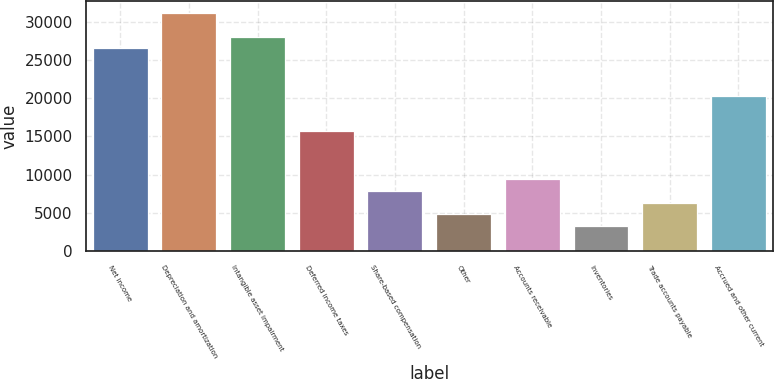Convert chart to OTSL. <chart><loc_0><loc_0><loc_500><loc_500><bar_chart><fcel>Net income<fcel>Depreciation and amortization<fcel>Intangible asset impairment<fcel>Deferred income taxes<fcel>Share-based compensation<fcel>Other<fcel>Accounts receivable<fcel>Inventories<fcel>Trade accounts payable<fcel>Accrued and other current<nl><fcel>26519.9<fcel>31178<fcel>28072.6<fcel>15651<fcel>7887.5<fcel>4782.1<fcel>9440.2<fcel>3229.4<fcel>6334.8<fcel>20309.1<nl></chart> 